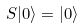Convert formula to latex. <formula><loc_0><loc_0><loc_500><loc_500>S | 0 \rangle = | 0 \rangle</formula> 